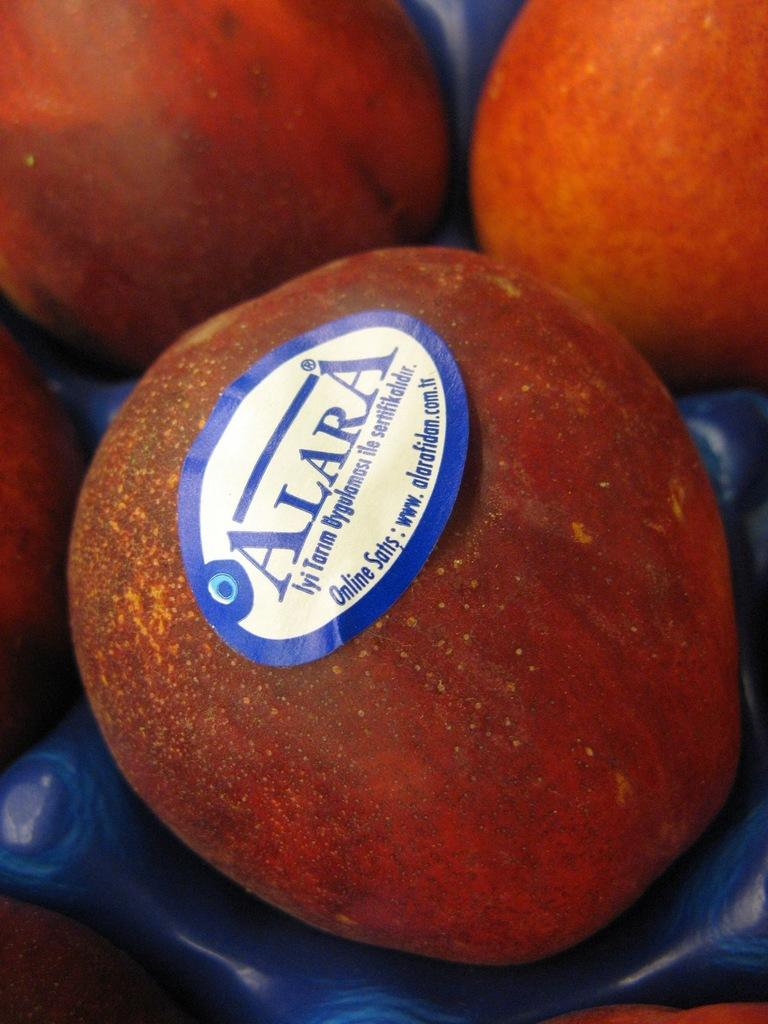What type of fruit is present in the image? There are apples in the image. Is there any additional detail on any of the apples? Yes, there is a sticker on one of the apples. Where is the stickered apple located in the image? The stickered apple is in the middle of the image. What type of pan is visible in the image? There is no pan present in the image. Are there any shoes visible in the image? There are no shoes present in the image. 